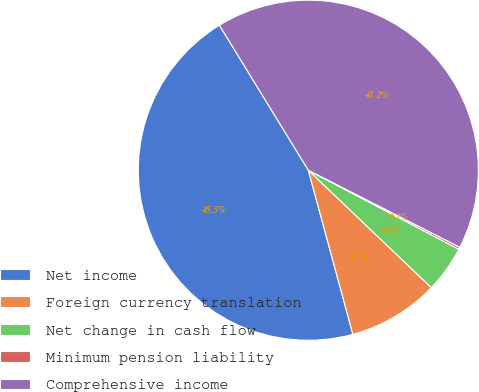<chart> <loc_0><loc_0><loc_500><loc_500><pie_chart><fcel>Net income<fcel>Foreign currency translation<fcel>Net change in cash flow<fcel>Minimum pension liability<fcel>Comprehensive income<nl><fcel>45.46%<fcel>8.65%<fcel>4.43%<fcel>0.21%<fcel>41.24%<nl></chart> 